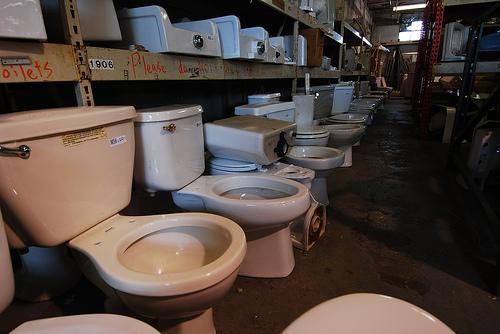Question: where was this picture taken?
Choices:
A. It was taken in a baseball stadium.
B. It was taken in a warehouse.
C. It was taken in a shopping mall.
D. It was taken in a school classroom.
Answer with the letter. Answer: B Question: what color are the toilets?
Choices:
A. The toilets are white.
B. Blue.
C. Red.
D. Green.
Answer with the letter. Answer: A Question: why was this picture taken?
Choices:
A. To show somebody where the bathroom is.
B. To demonstrate how to properly install a toilet.
C. To prove that toilets travel in herds.
D. To show what the toilets look like in the warehouse.
Answer with the letter. Answer: D Question: what is on the shelf above the toilets?
Choices:
A. Kitchen sinks are on the shelf.
B. Bathroom vanity mirrors are on the shelf.
C. Wall toilets are on the shelf.
D. Clothes hampers are on the shelf.
Answer with the letter. Answer: C 